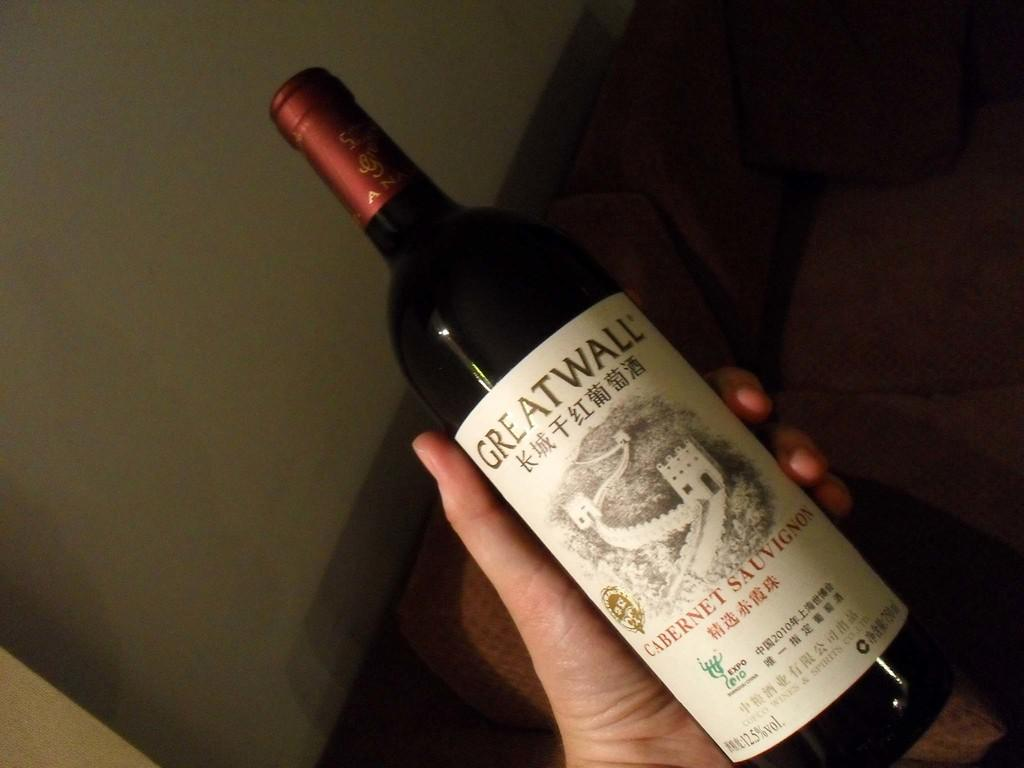<image>
Summarize the visual content of the image. A hand holding a bottle of 2010 Greatwall Cabernet Sauvigon 